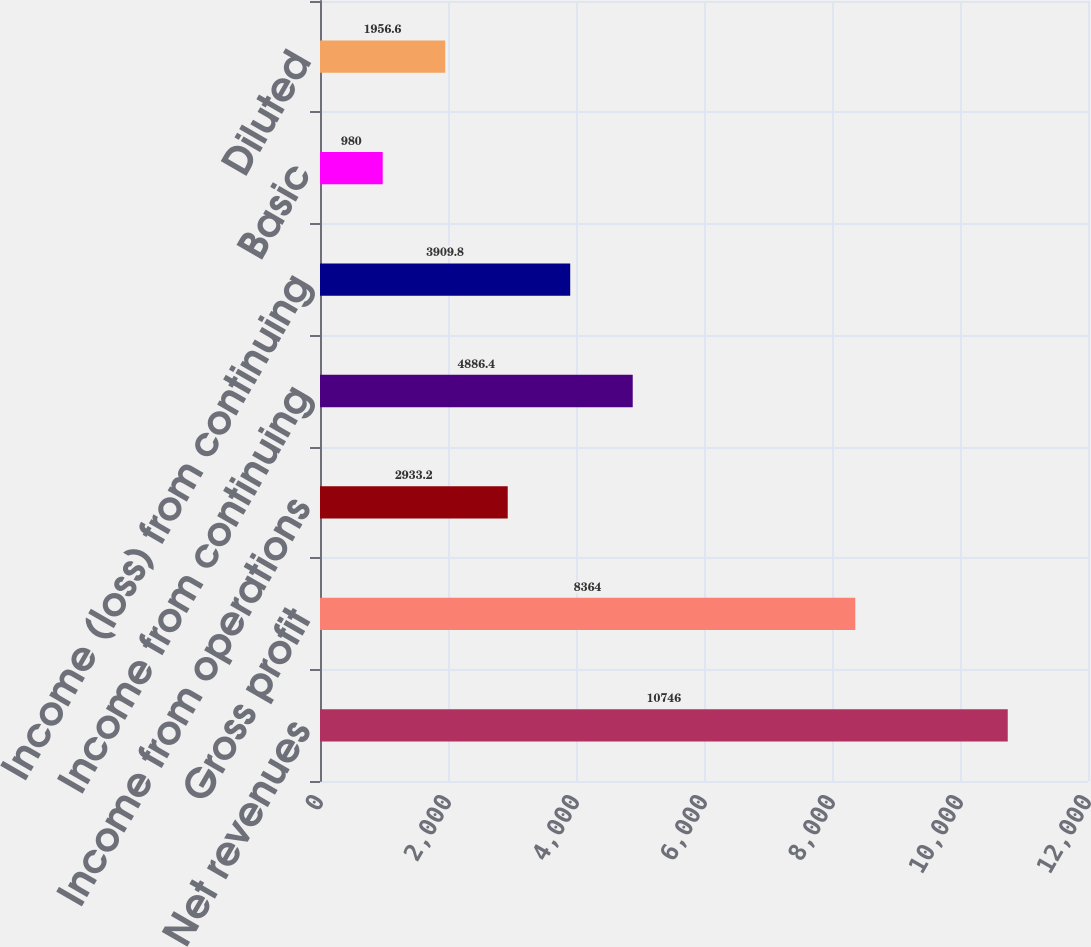Convert chart to OTSL. <chart><loc_0><loc_0><loc_500><loc_500><bar_chart><fcel>Net revenues<fcel>Gross profit<fcel>Income from operations<fcel>Income from continuing<fcel>Income (loss) from continuing<fcel>Basic<fcel>Diluted<nl><fcel>10746<fcel>8364<fcel>2933.2<fcel>4886.4<fcel>3909.8<fcel>980<fcel>1956.6<nl></chart> 